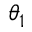<formula> <loc_0><loc_0><loc_500><loc_500>\theta _ { 1 }</formula> 